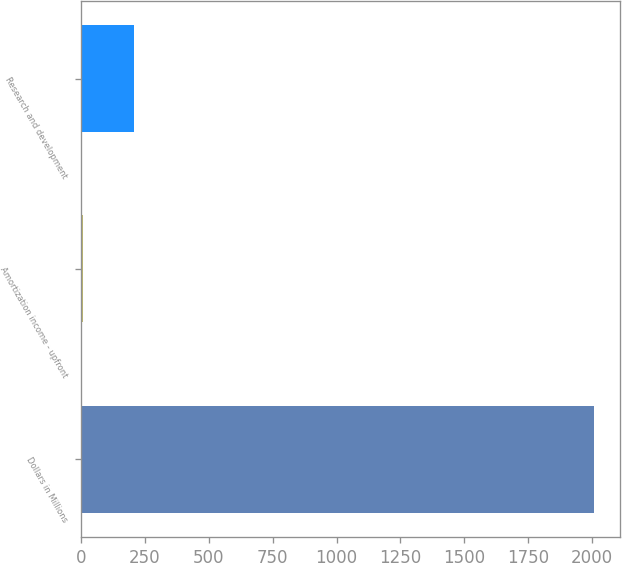<chart> <loc_0><loc_0><loc_500><loc_500><bar_chart><fcel>Dollars in Millions<fcel>Amortization income - upfront<fcel>Research and development<nl><fcel>2008<fcel>9<fcel>208.9<nl></chart> 